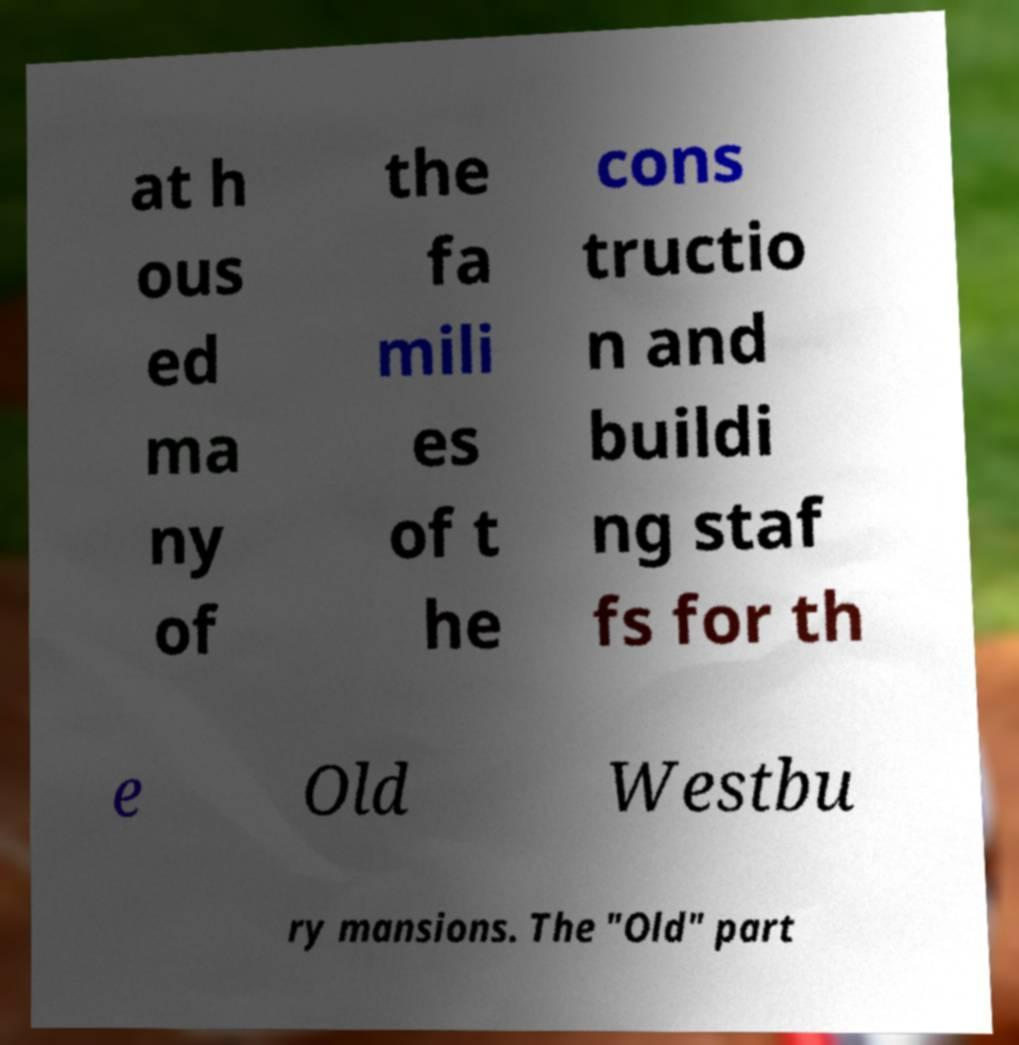Could you assist in decoding the text presented in this image and type it out clearly? at h ous ed ma ny of the fa mili es of t he cons tructio n and buildi ng staf fs for th e Old Westbu ry mansions. The "Old" part 